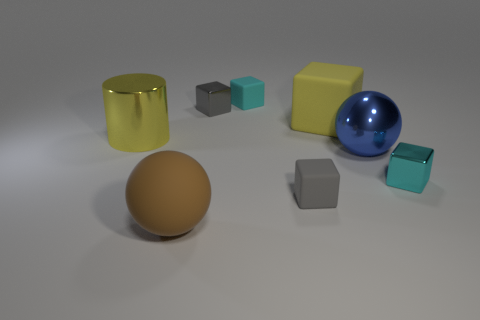Are there any other things that are the same shape as the yellow metal object?
Your answer should be very brief. No. Is the size of the yellow thing that is right of the big rubber sphere the same as the cyan metal thing that is right of the gray matte block?
Your answer should be very brief. No. How many big rubber cubes have the same color as the shiny cylinder?
Make the answer very short. 1. Do the shiny sphere and the sphere that is in front of the big blue metallic thing have the same size?
Your answer should be compact. Yes. There is a tiny gray block behind the yellow shiny cylinder; what is it made of?
Your answer should be very brief. Metal. Is the number of small cyan shiny cubes that are behind the cylinder the same as the number of blue matte things?
Your answer should be very brief. Yes. Is the cyan metal thing the same size as the cyan rubber block?
Provide a short and direct response. Yes. There is a large matte thing that is to the right of the brown matte object left of the big blue shiny thing; are there any small shiny objects that are on the right side of it?
Your response must be concise. Yes. What material is the large yellow thing that is the same shape as the small gray matte object?
Ensure brevity in your answer.  Rubber. There is a rubber block behind the yellow block; what number of cyan shiny cubes are behind it?
Offer a very short reply. 0. 